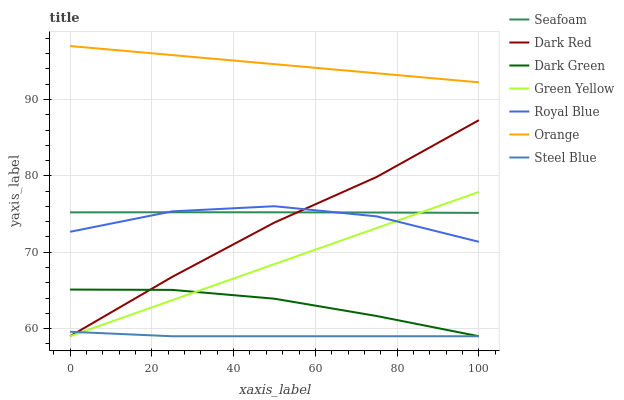Does Steel Blue have the minimum area under the curve?
Answer yes or no. Yes. Does Orange have the maximum area under the curve?
Answer yes or no. Yes. Does Seafoam have the minimum area under the curve?
Answer yes or no. No. Does Seafoam have the maximum area under the curve?
Answer yes or no. No. Is Green Yellow the smoothest?
Answer yes or no. Yes. Is Royal Blue the roughest?
Answer yes or no. Yes. Is Seafoam the smoothest?
Answer yes or no. No. Is Seafoam the roughest?
Answer yes or no. No. Does Dark Red have the lowest value?
Answer yes or no. Yes. Does Seafoam have the lowest value?
Answer yes or no. No. Does Orange have the highest value?
Answer yes or no. Yes. Does Seafoam have the highest value?
Answer yes or no. No. Is Seafoam less than Orange?
Answer yes or no. Yes. Is Orange greater than Green Yellow?
Answer yes or no. Yes. Does Dark Red intersect Dark Green?
Answer yes or no. Yes. Is Dark Red less than Dark Green?
Answer yes or no. No. Is Dark Red greater than Dark Green?
Answer yes or no. No. Does Seafoam intersect Orange?
Answer yes or no. No. 